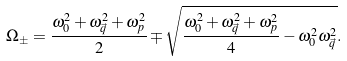<formula> <loc_0><loc_0><loc_500><loc_500>\Omega _ { \pm } = \frac { \omega _ { 0 } ^ { 2 } + \omega _ { \vec { q } } ^ { 2 } + \omega _ { p } ^ { 2 } } { 2 } \mp \sqrt { \frac { \omega _ { 0 } ^ { 2 } + \omega _ { \vec { q } } ^ { 2 } + \omega _ { p } ^ { 2 } } { 4 } - \omega _ { 0 } ^ { 2 } \omega _ { \vec { q } } ^ { 2 } } .</formula> 